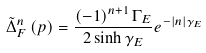Convert formula to latex. <formula><loc_0><loc_0><loc_500><loc_500>\tilde { \Delta } _ { F } ^ { n } \left ( p \right ) = \frac { \left ( - 1 \right ) ^ { n + 1 } \Gamma _ { E } } { 2 \sinh \gamma _ { E } } e ^ { - | n | \gamma _ { E } }</formula> 